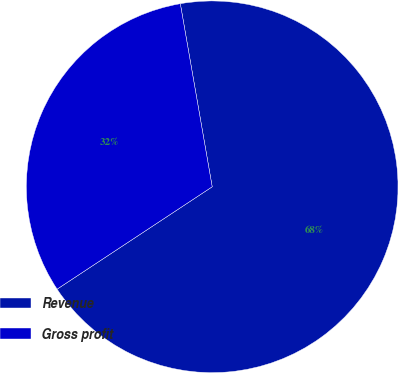Convert chart to OTSL. <chart><loc_0><loc_0><loc_500><loc_500><pie_chart><fcel>Revenue<fcel>Gross profit<nl><fcel>68.46%<fcel>31.54%<nl></chart> 